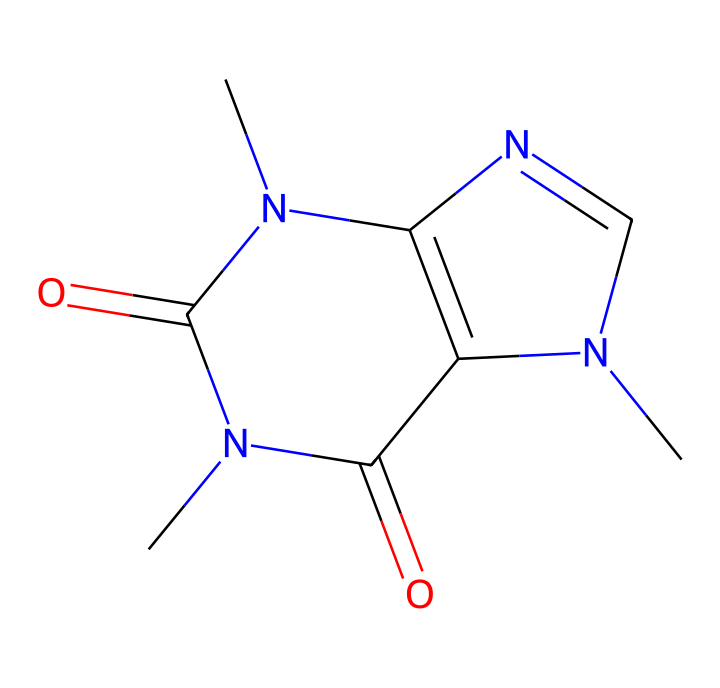How many nitrogen atoms are present in this chemical structure? By examining the SMILES representation, we can identify the nitrogen (N) atoms within the structure. In this case, there are three nitrogen atoms present.
Answer: three What is the chemical name of this compound? The SMILES representation corresponds to caffeine, which is a well-known stimulant commonly found in coffee and tea.
Answer: caffeine How many rings are present in the chemical structure? Analyzing the structure, we can see two fused rings within the caffeine molecule, which is typical for many alkaloids.
Answer: two What functional groups are indicated in the structure? The structure contains amine groups (indicated by the nitrogen atoms) and carbonyl groups (indicated by the C=O connections), characteristic of caffeine's chemical properties.
Answer: amine and carbonyl What is the molecular formula of caffeine represented in this structure? By counting the atoms of each element from the SMILES, we can deduce the molecular formula of caffeine, which is C8H10N4O2.
Answer: C8H10N4O2 How does the presence of nitrogen atoms contribute to the properties of caffeine? The nitrogen atoms in caffeine contribute to its classification as an alkaloid, influencing its physiological effects, such as being a central nervous system stimulant.
Answer: influences stimulant effects 